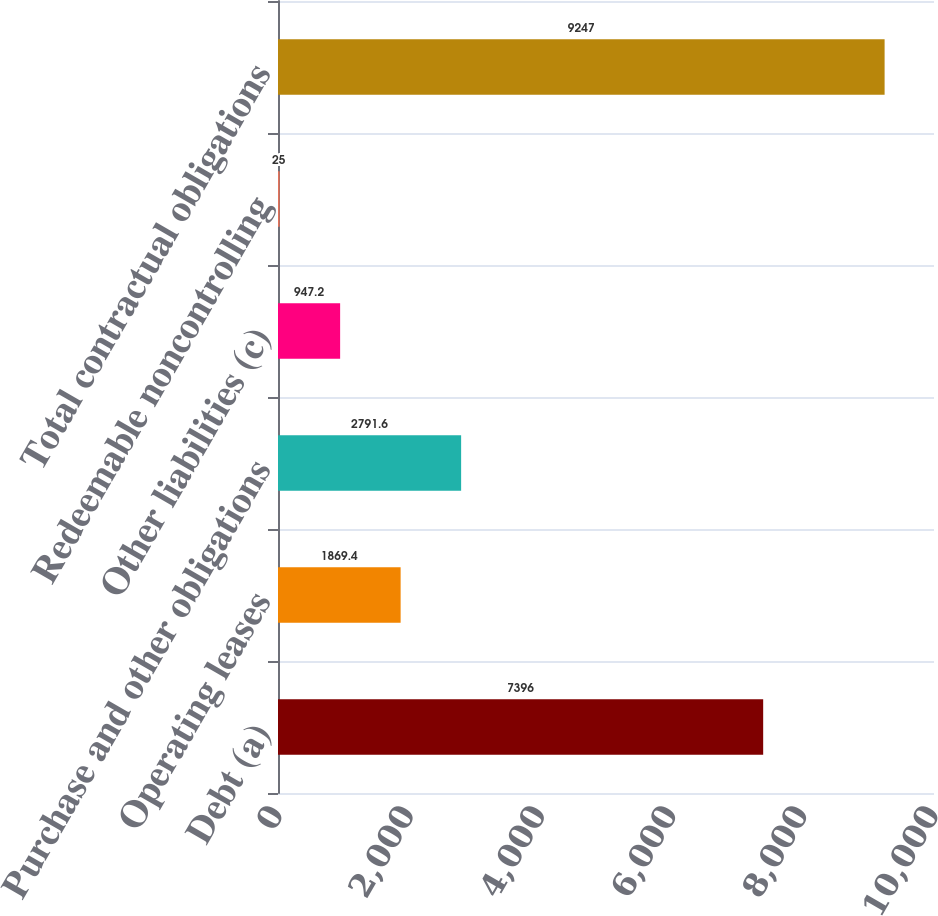<chart> <loc_0><loc_0><loc_500><loc_500><bar_chart><fcel>Debt (a)<fcel>Operating leases<fcel>Purchase and other obligations<fcel>Other liabilities (c)<fcel>Redeemable noncontrolling<fcel>Total contractual obligations<nl><fcel>7396<fcel>1869.4<fcel>2791.6<fcel>947.2<fcel>25<fcel>9247<nl></chart> 